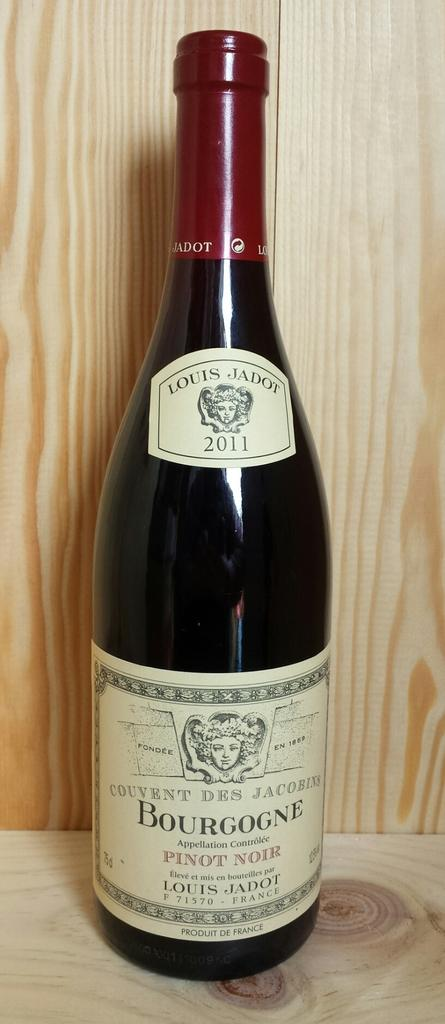<image>
Render a clear and concise summary of the photo. Bourgogne Wine Bottle from the brand Louis Jadot made in 2011. 